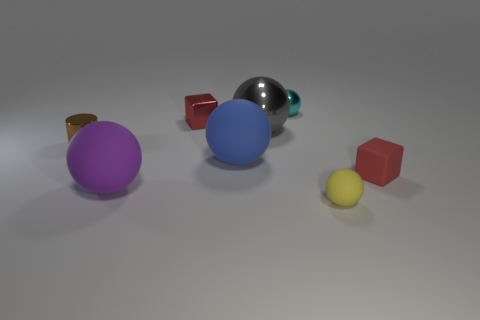Is the number of cyan objects on the right side of the big purple rubber ball greater than the number of small matte blocks that are right of the small brown metallic thing?
Provide a succinct answer. No. Are there any tiny shiny cubes on the right side of the big blue ball?
Your answer should be compact. No. There is a tiny thing that is in front of the tiny red shiny object and to the left of the tiny cyan object; what is its material?
Provide a short and direct response. Metal. The other tiny thing that is the same shape as the red metallic object is what color?
Offer a terse response. Red. There is a red thing that is on the left side of the yellow object; is there a metal block right of it?
Ensure brevity in your answer.  No. The yellow sphere is what size?
Your answer should be compact. Small. What is the shape of the tiny thing that is both in front of the tiny cyan object and behind the cylinder?
Offer a very short reply. Cube. How many brown things are tiny blocks or big shiny things?
Your answer should be compact. 0. Do the red object that is left of the matte block and the cyan shiny object that is behind the tiny brown cylinder have the same size?
Provide a succinct answer. Yes. How many objects are small cyan things or rubber blocks?
Ensure brevity in your answer.  2. 